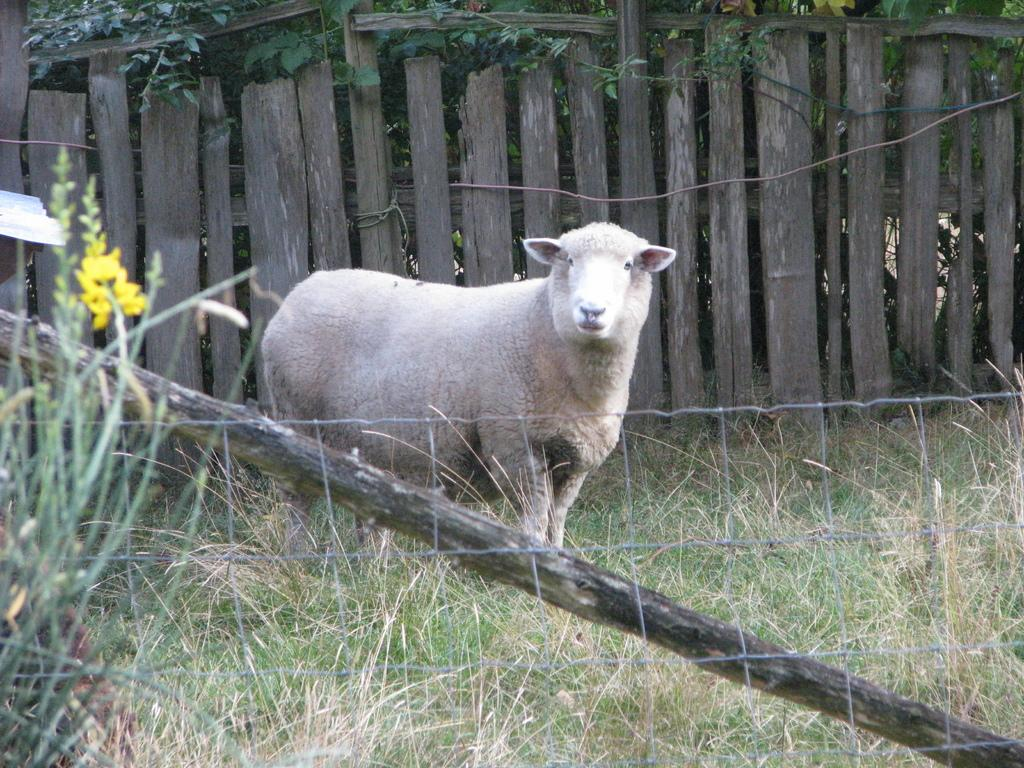What animal is standing in the middle of the image? There is a sheep standing in the middle of the image. What type of material is the wall made of in the image? There is a wooden wall in the image. What type of wax can be seen dripping from the sheep's lip in the image? There is no wax or lip present on the sheep in the image. 